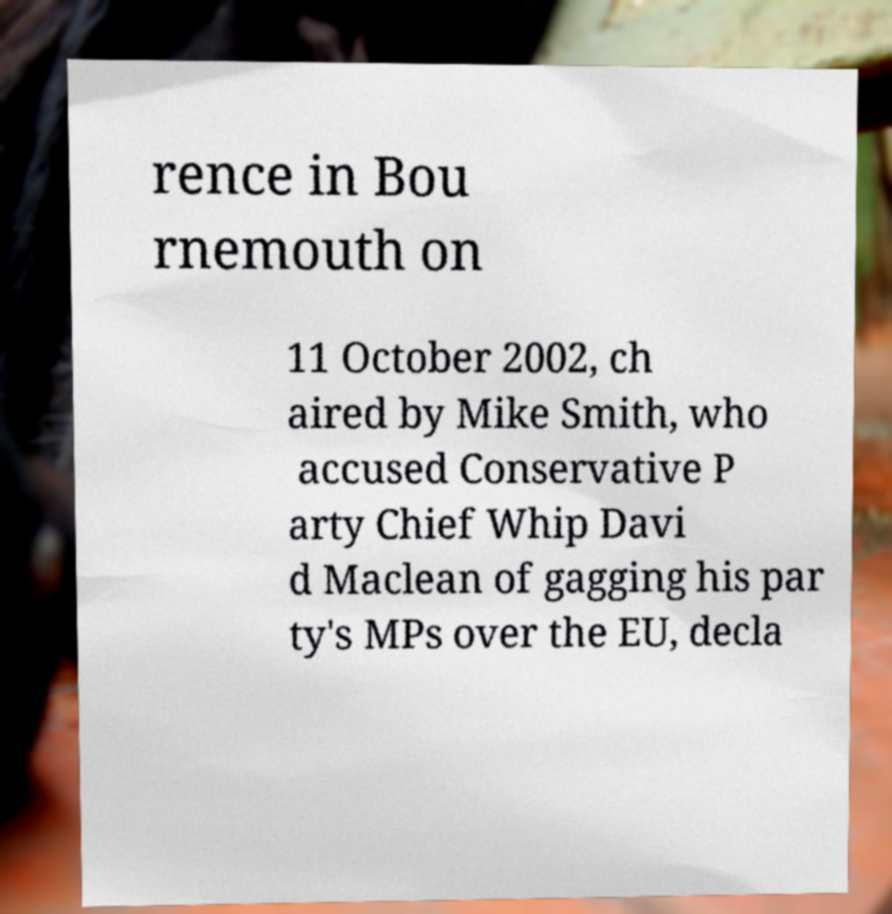Could you assist in decoding the text presented in this image and type it out clearly? rence in Bou rnemouth on 11 October 2002, ch aired by Mike Smith, who accused Conservative P arty Chief Whip Davi d Maclean of gagging his par ty's MPs over the EU, decla 